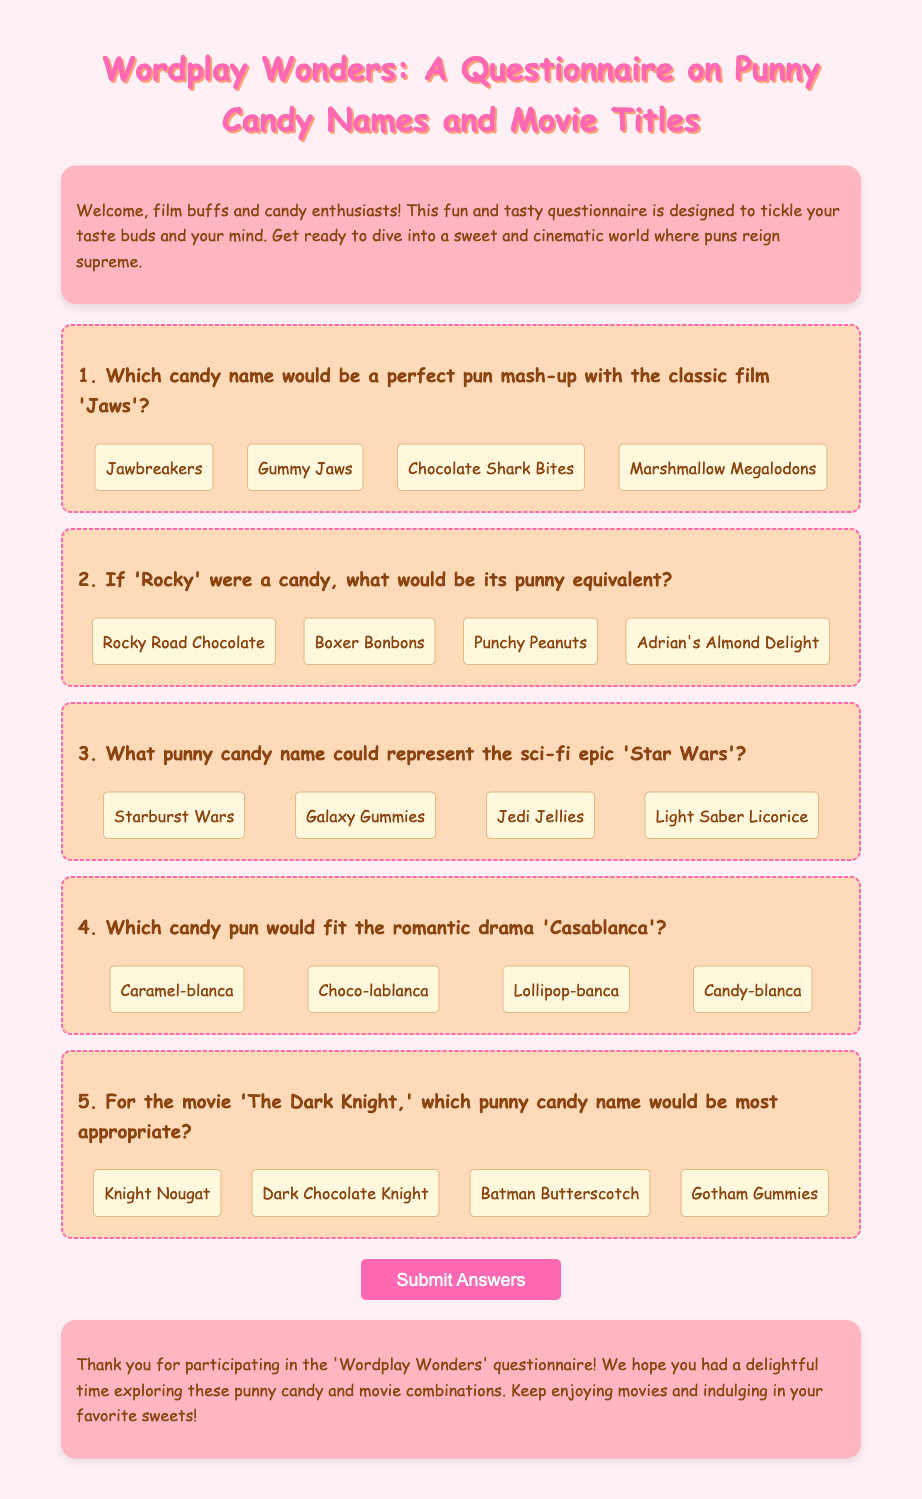What is the title of the questionnaire? The title of the questionnaire is explicitly mentioned at the top of the document.
Answer: Wordplay Wonders: A Questionnaire on Punny Candy Names and Movie Titles How many questions are in the questionnaire? The document contains several sections, each labeled as a question. Counting these reveals the total number of questions.
Answer: 5 What is the first punny candy name option for 'Jaws'? The options for the candy pun mash-up with 'Jaws' are listed under the first question.
Answer: Jawbreakers Which candy pun name corresponds with the movie 'Rocky'? The second question involves choices related to the movie 'Rocky' indicating possible punny candy names.
Answer: Rocky Road Chocolate What punny candy name represents 'Star Wars'? The third question offers multiple pun-related candy names for the movie 'Star Wars'.
Answer: Starburst Wars What background color is used for the intro section? The intro section of the document specifies its background color, which can be identified visually.
Answer: #FFB6C1 What is the color of the submit button? The document specifies the background color of the submit button prominently.
Answer: #FF69B4 What kind of font is used in the document? The document specifies the font used for the body of the text.
Answer: Comic Sans MS 